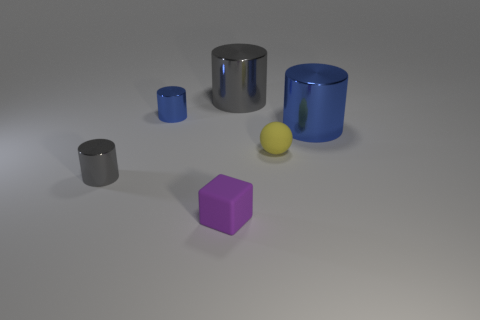Subtract all tiny blue metal cylinders. How many cylinders are left? 3 Subtract all blue cylinders. How many cylinders are left? 2 Add 4 gray cubes. How many objects exist? 10 Subtract all spheres. How many objects are left? 5 Add 5 gray things. How many gray things exist? 7 Subtract 0 blue spheres. How many objects are left? 6 Subtract 2 cylinders. How many cylinders are left? 2 Subtract all blue cubes. Subtract all green balls. How many cubes are left? 1 Subtract all red cylinders. How many yellow cubes are left? 0 Subtract all big purple metallic blocks. Subtract all cylinders. How many objects are left? 2 